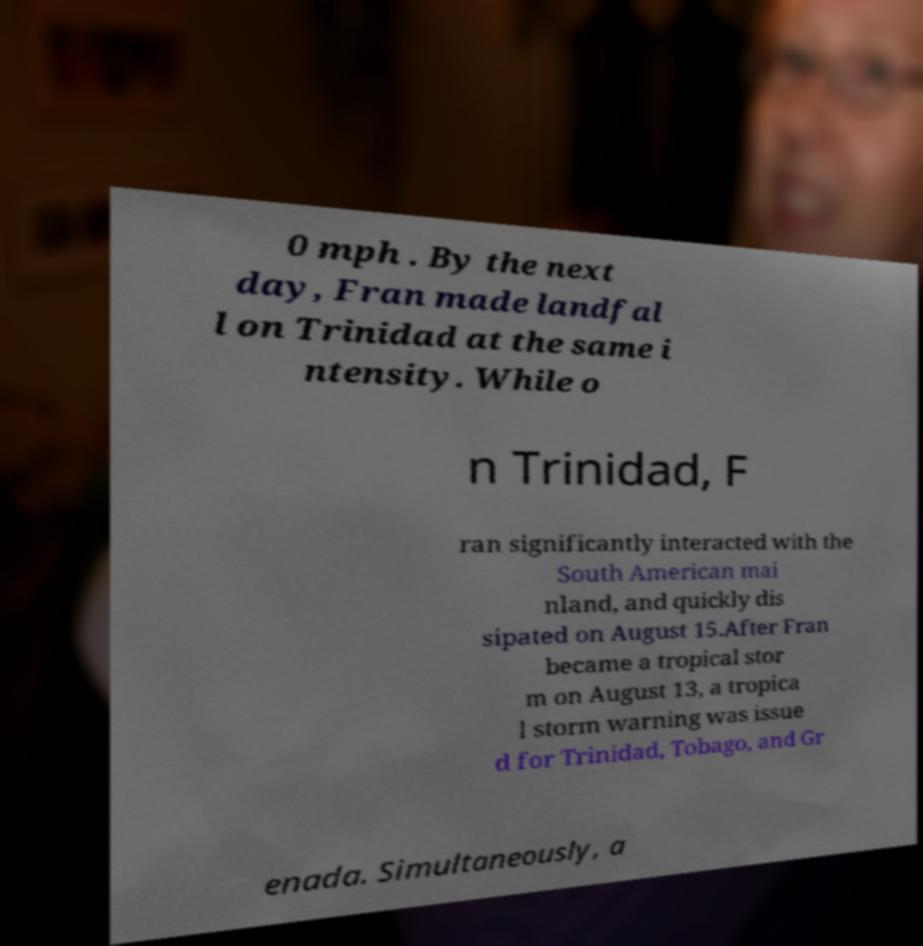Could you extract and type out the text from this image? 0 mph . By the next day, Fran made landfal l on Trinidad at the same i ntensity. While o n Trinidad, F ran significantly interacted with the South American mai nland, and quickly dis sipated on August 15.After Fran became a tropical stor m on August 13, a tropica l storm warning was issue d for Trinidad, Tobago, and Gr enada. Simultaneously, a 